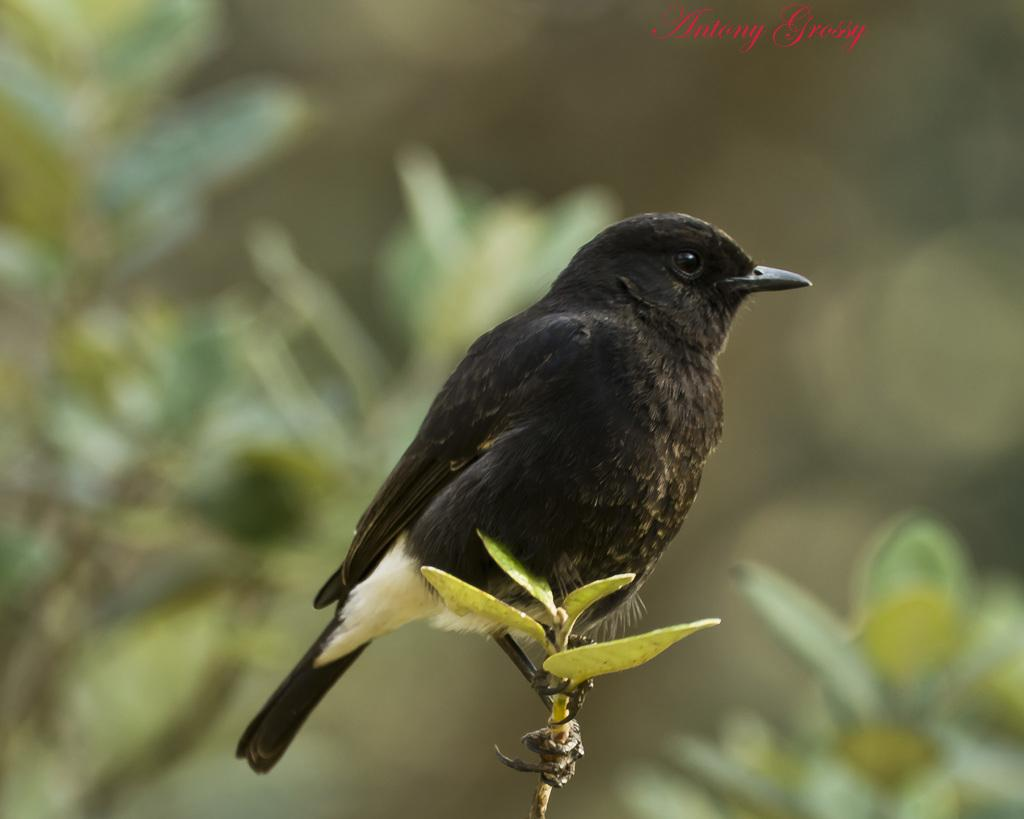What type of bird can be seen in the image? There is a black color bird in the image. What can be observed in the background of the image? The background of the image is blurry with leaves. What is written at the top of the image? There is red color text at the top of the image. Can you tell me how many visitors are sitting at the table in the image? There is no table or visitors present in the image; it features a black color bird and a blurry background with leaves. 